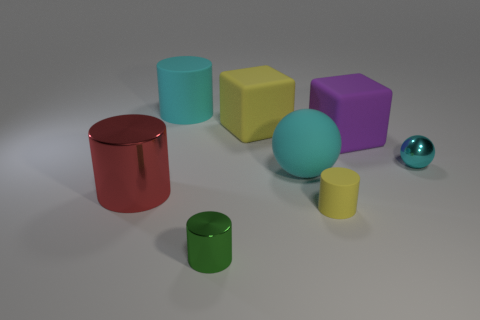The cyan shiny ball has what size?
Provide a short and direct response. Small. What number of blue objects are either rubber spheres or balls?
Your answer should be very brief. 0. There is a cylinder behind the big matte block left of the small yellow thing; what size is it?
Offer a very short reply. Large. Is the color of the small rubber cylinder the same as the big block to the left of the large purple block?
Offer a terse response. Yes. How many other objects are there of the same material as the tiny sphere?
Your answer should be very brief. 2. What is the shape of the red object that is made of the same material as the green cylinder?
Provide a short and direct response. Cylinder. Are there any other things of the same color as the small metal cylinder?
Your response must be concise. No. What is the size of the metallic thing that is the same color as the large ball?
Provide a succinct answer. Small. Are there more big red cylinders that are left of the large red thing than small yellow things?
Make the answer very short. No. There is a purple thing; is it the same shape as the tiny object that is behind the tiny matte cylinder?
Your answer should be compact. No. 